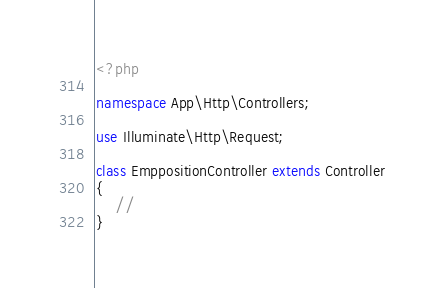Convert code to text. <code><loc_0><loc_0><loc_500><loc_500><_PHP_><?php

namespace App\Http\Controllers;

use Illuminate\Http\Request;

class EmppositionController extends Controller
{
    //
}
</code> 